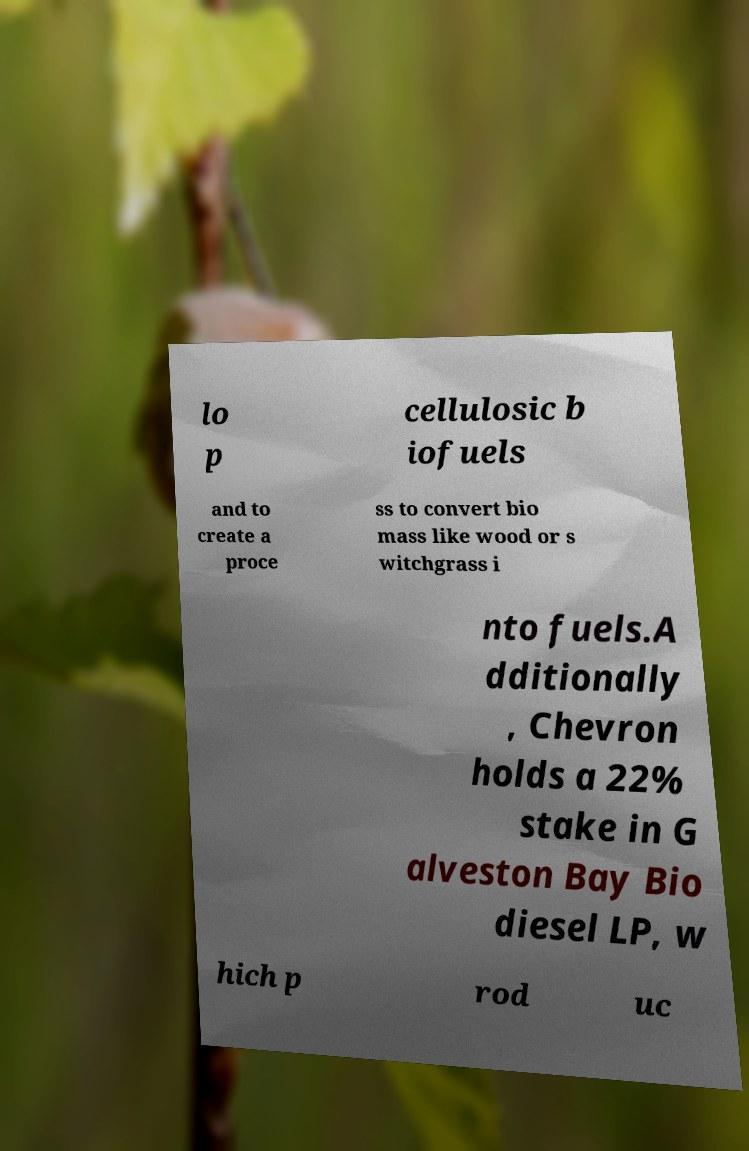Could you assist in decoding the text presented in this image and type it out clearly? lo p cellulosic b iofuels and to create a proce ss to convert bio mass like wood or s witchgrass i nto fuels.A dditionally , Chevron holds a 22% stake in G alveston Bay Bio diesel LP, w hich p rod uc 